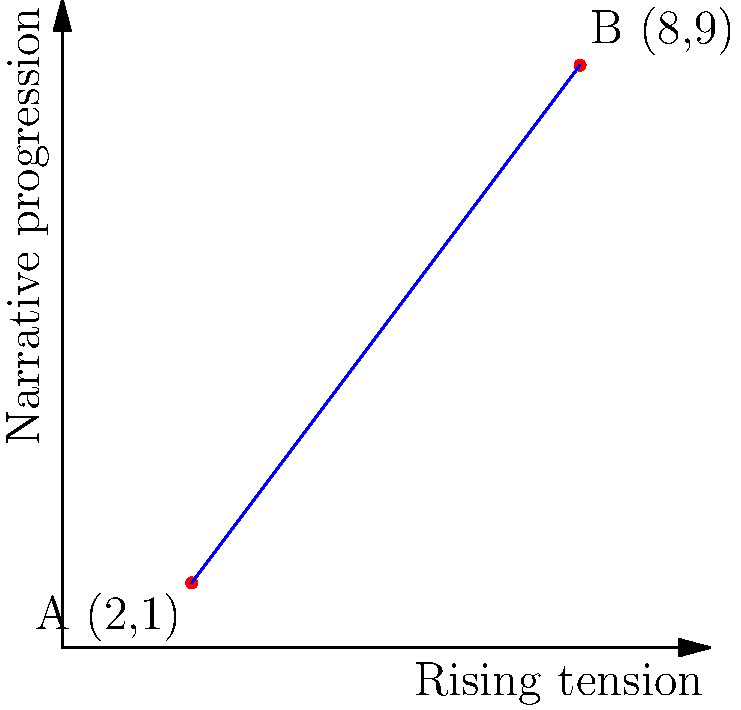In your latest novel, you've plotted the rising tension against the narrative progression. Two critical points in your story arc are represented by A (2,1) and B (8,9) on the graph. Calculate the slope of the line passing through these points, which represents the rate at which tension builds in your narrative. How would you interpret this slope in terms of your storytelling technique? To find the slope of the line passing through points A (2,1) and B (8,9), we'll use the slope formula:

$$ m = \frac{y_2 - y_1}{x_2 - x_1} $$

Where $(x_1, y_1)$ is the first point and $(x_2, y_2)$ is the second point.

Step 1: Identify the coordinates
Point A: $(x_1, y_1) = (2, 1)$
Point B: $(x_2, y_2) = (8, 9)$

Step 2: Substitute these values into the slope formula
$$ m = \frac{9 - 1}{8 - 2} = \frac{8}{6} $$

Step 3: Simplify the fraction
$$ m = \frac{4}{3} \approx 1.33 $$

Interpretation: The slope of $\frac{4}{3}$ indicates a steady increase in tension throughout the narrative. For every 3 units of narrative progression, the tension rises by 4 units. This suggests a well-paced, gradually intensifying plot that maintains reader engagement without overwhelming them with sudden dramatic shifts.
Answer: $\frac{4}{3}$ 